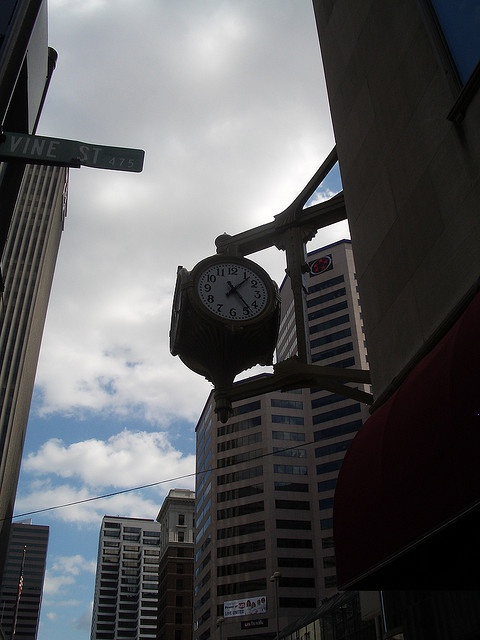Describe the objects in this image and their specific colors. I can see a clock in black, gray, and lightgray tones in this image. 